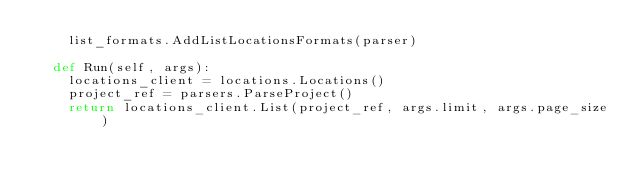<code> <loc_0><loc_0><loc_500><loc_500><_Python_>    list_formats.AddListLocationsFormats(parser)

  def Run(self, args):
    locations_client = locations.Locations()
    project_ref = parsers.ParseProject()
    return locations_client.List(project_ref, args.limit, args.page_size)
</code> 